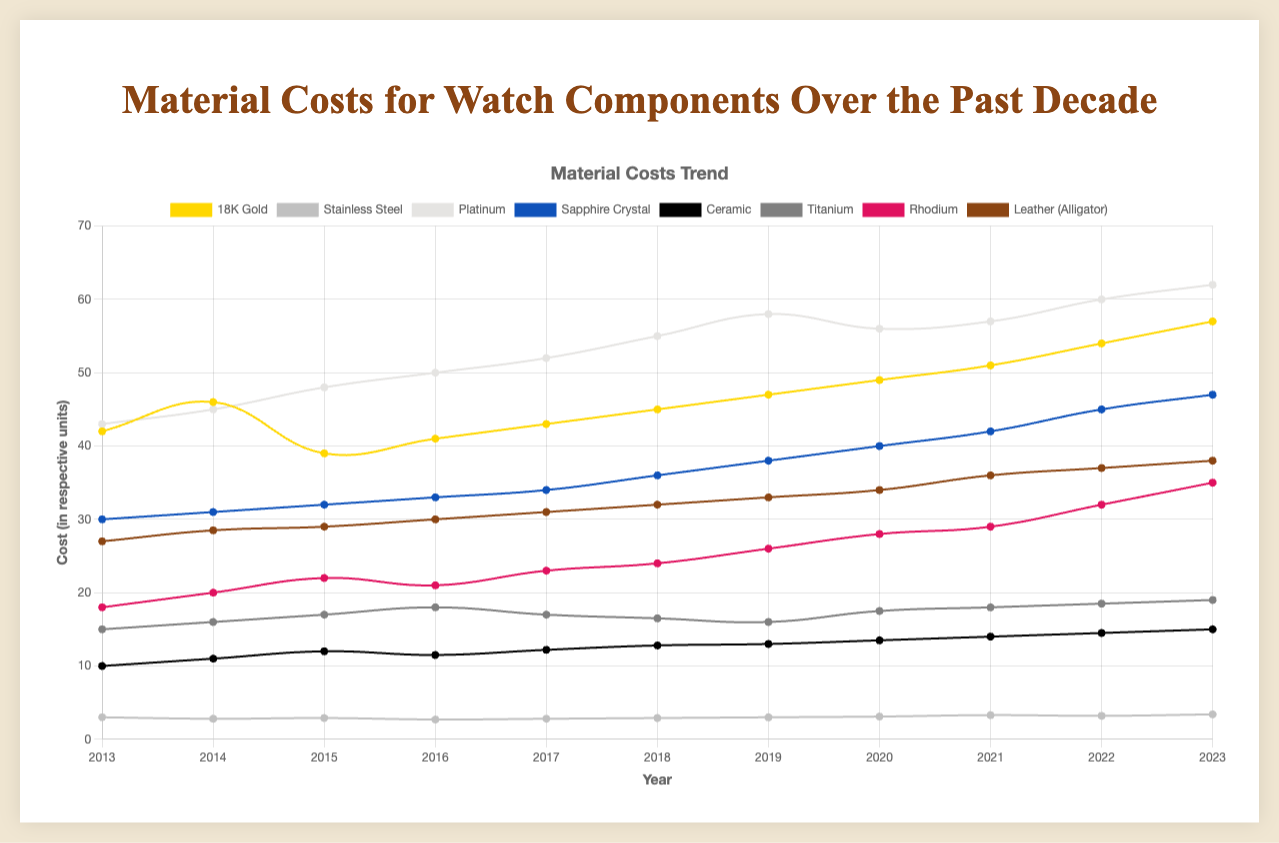Which material had the highest cost per unit in 2023? Looking at the figure, the material with the highest point on the y-axis for the year 2023 is Platinum.
Answer: Platinum Which year did 18K Gold and Rhodium first cross paths in their cost per unit? By observing the point where the lines for 18K Gold and Rhodium intersect, we see the crossover occurs around the year 2022.
Answer: 2022 What's the average cost per kilogram of Stainless Steel from 2019 to 2023? The costs for Stainless Steel from 2019 to 2023 are 3, 3.1, 3.3, 3.2, and 3.4. Summing these values gives 16, and dividing by 5 years gives an average cost of 3.2.
Answer: 3.2 Which material showed the most significant increase in cost per unit from 2018 to 2023? By calculating the difference in costs between 2018 and 2023 for each material, Platinum (62 - 55 = 7) had the highest increase among all.
Answer: Platinum Which materials' costs were lower at the end of the decade compared to the start? By comparing the costs of all materials in 2013 and 2023, we see Stainless Steel (3 to 3.4), Leather (Alligator) (27 to 38), and Titanium (15 to 19) had increases, with no materials showing lower costs.
Answer: None Which material saw a drop in cost between any consecutive years? By checking the data points year by year, Stainless Steel had a drop from 2014 to 2015 (2.8 to 2.7), and Rhodium fell from 2016 to 2017 (21 to 23).
Answer: Stainless Steel, Rhodium What is the average cost per gram of 18K Gold from 2016 to 2023? The costs from 2016 to 2023 are 41, 43, 45, 47, 49, 51, 54, 57. Summing these gives 387, dividing by 8 years gives an average cost of ~48.375.
Answer: 48.375 Which year recorded the highest cost per square meter for Leather (Alligator)? Observing Leather (Alligator) throughout the decade, 2023 shows the highest cost at 38.
Answer: 2023 Which materials had higher total cost growth than Stainless Steel from 2013 to 2023? The total increase for Stainless Steel (3 to 3.4) is 0.4. Materials with a higher increase are 18K Gold (42 to 57 = 15), Platinum (43 to 62 = 19), Sapphire Crystal (30 to 47 = 17), Ceramic (10 to 15 = 5), Titanium (15 to 19 = 4), and Rhodium (18 to 35 = 17) all had higher growth.
Answer: 18K Gold, Platinum, Sapphire Crystal, Ceramic, Titanium, Rhodium Which material showed the smoothest upward trend in cost per unit over the decade? Sapphire Crystal's cost increases consistently, without significant drops or irregular jumps.
Answer: Sapphire Crystal 